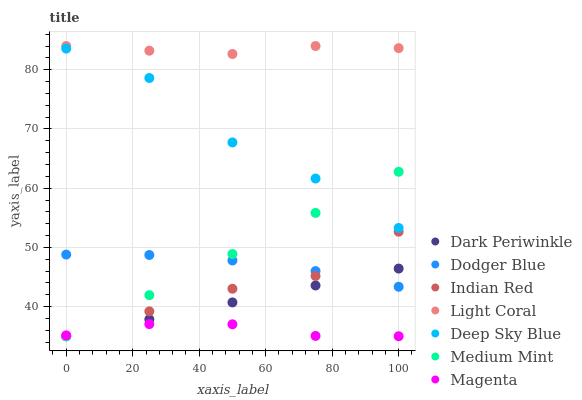Does Magenta have the minimum area under the curve?
Answer yes or no. Yes. Does Light Coral have the maximum area under the curve?
Answer yes or no. Yes. Does Indian Red have the minimum area under the curve?
Answer yes or no. No. Does Indian Red have the maximum area under the curve?
Answer yes or no. No. Is Medium Mint the smoothest?
Answer yes or no. Yes. Is Deep Sky Blue the roughest?
Answer yes or no. Yes. Is Indian Red the smoothest?
Answer yes or no. No. Is Indian Red the roughest?
Answer yes or no. No. Does Medium Mint have the lowest value?
Answer yes or no. Yes. Does Light Coral have the lowest value?
Answer yes or no. No. Does Light Coral have the highest value?
Answer yes or no. Yes. Does Indian Red have the highest value?
Answer yes or no. No. Is Dark Periwinkle less than Deep Sky Blue?
Answer yes or no. Yes. Is Light Coral greater than Dodger Blue?
Answer yes or no. Yes. Does Medium Mint intersect Deep Sky Blue?
Answer yes or no. Yes. Is Medium Mint less than Deep Sky Blue?
Answer yes or no. No. Is Medium Mint greater than Deep Sky Blue?
Answer yes or no. No. Does Dark Periwinkle intersect Deep Sky Blue?
Answer yes or no. No. 